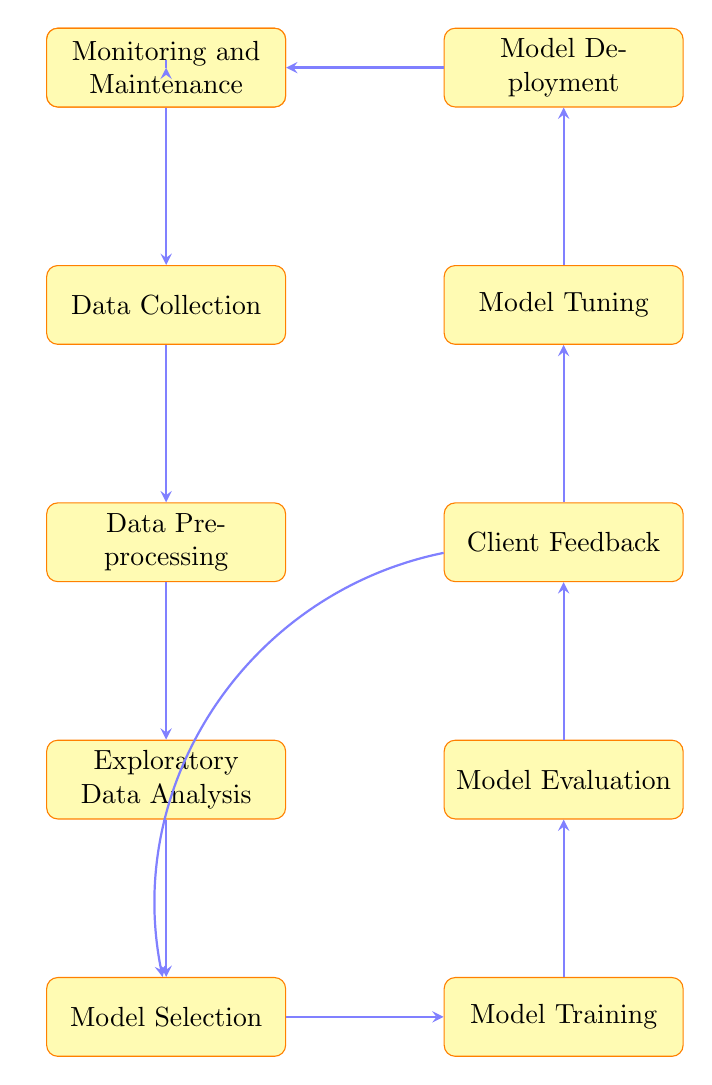What is the first step in the diagram? The first node in the diagram is "Client Requirement Gathering," which indicates that this is the initial stage of the process.
Answer: Client Requirement Gathering How many total nodes are present in the flow chart? By counting each distinct process node in the diagram, we find a total of eleven nodes.
Answer: Eleven What follows Data Preprocessing in the flow chart? According to the directional arrows in the diagram, the node that follows Data Preprocessing is Exploratory Data Analysis.
Answer: Exploratory Data Analysis Identify the process that directly leads to Model Deployment. The node directly preceding Model Deployment is Model Tuning, which indicates that tuning the model happens before deployment.
Answer: Model Tuning Which two nodes have a feedback loop between them? The feedback mechanism is evident from the arrow pointing from Client Feedback back to Model Selection, indicating that feedback affects model selection decisions.
Answer: Client Feedback and Model Selection What is the last process in the flow chart? The final node in the sequence of the diagram is Monitoring and Maintenance, marking the concluding stage in the described pathway.
Answer: Monitoring and Maintenance What is the purpose of the Monitoring and Maintenance process? As shown in the flow chart, Monitoring and Maintenance is the step that ensures the model's performance is continuously checked and adjusted for consistent operation after deployment.
Answer: Continuously monitor model performance Which nodes are connected by the arrow that bends to the left? The left-bending arrow connects Monitoring and Maintenance back to Client Requirement Gathering, indicating a cycle where client needs may influence ongoing model adjustments.
Answer: Monitoring and Maintenance to Client Requirement Gathering 